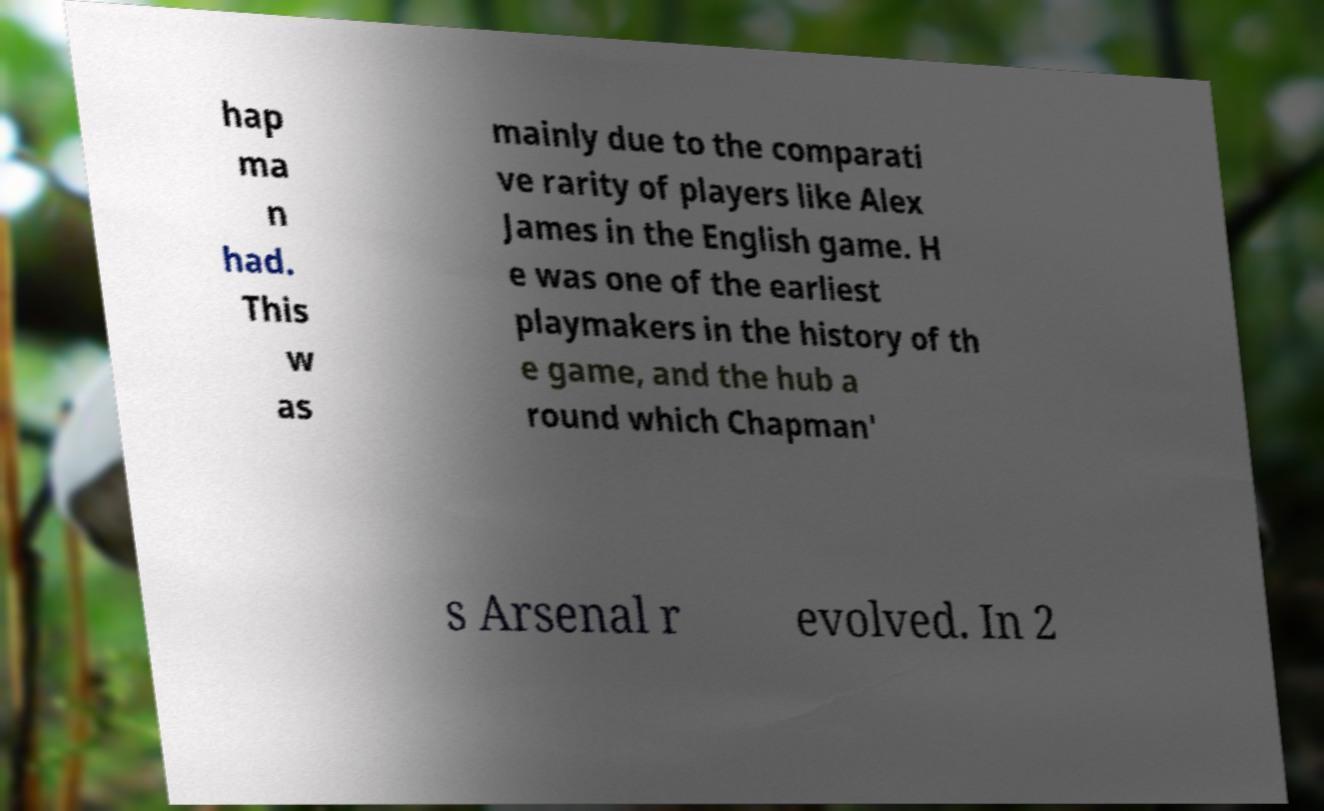There's text embedded in this image that I need extracted. Can you transcribe it verbatim? hap ma n had. This w as mainly due to the comparati ve rarity of players like Alex James in the English game. H e was one of the earliest playmakers in the history of th e game, and the hub a round which Chapman' s Arsenal r evolved. In 2 